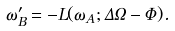<formula> <loc_0><loc_0><loc_500><loc_500>\omega ^ { \prime } _ { B } = - L ( \omega _ { A } ; \Delta \Omega - \Phi ) .</formula> 